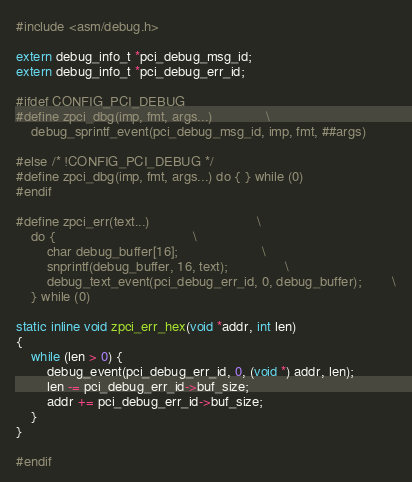<code> <loc_0><loc_0><loc_500><loc_500><_C_>#include <asm/debug.h>

extern debug_info_t *pci_debug_msg_id;
extern debug_info_t *pci_debug_err_id;

#ifdef CONFIG_PCI_DEBUG
#define zpci_dbg(imp, fmt, args...)				\
	debug_sprintf_event(pci_debug_msg_id, imp, fmt, ##args)

#else /* !CONFIG_PCI_DEBUG */
#define zpci_dbg(imp, fmt, args...) do { } while (0)
#endif

#define zpci_err(text...)							\
	do {									\
		char debug_buffer[16];						\
		snprintf(debug_buffer, 16, text);				\
		debug_text_event(pci_debug_err_id, 0, debug_buffer);		\
	} while (0)

static inline void zpci_err_hex(void *addr, int len)
{
	while (len > 0) {
		debug_event(pci_debug_err_id, 0, (void *) addr, len);
		len -= pci_debug_err_id->buf_size;
		addr += pci_debug_err_id->buf_size;
	}
}

#endif
</code> 